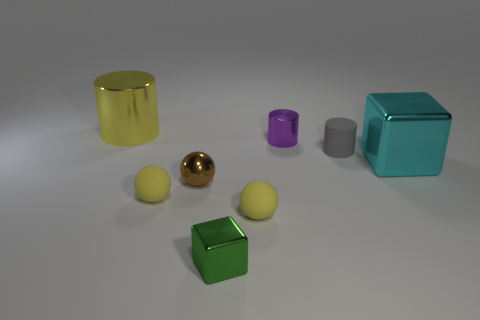Add 2 yellow matte balls. How many objects exist? 10 Subtract all blocks. How many objects are left? 6 Subtract 0 blue cylinders. How many objects are left? 8 Subtract all gray shiny blocks. Subtract all small brown metallic balls. How many objects are left? 7 Add 6 tiny gray rubber objects. How many tiny gray rubber objects are left? 7 Add 2 small purple shiny cylinders. How many small purple shiny cylinders exist? 3 